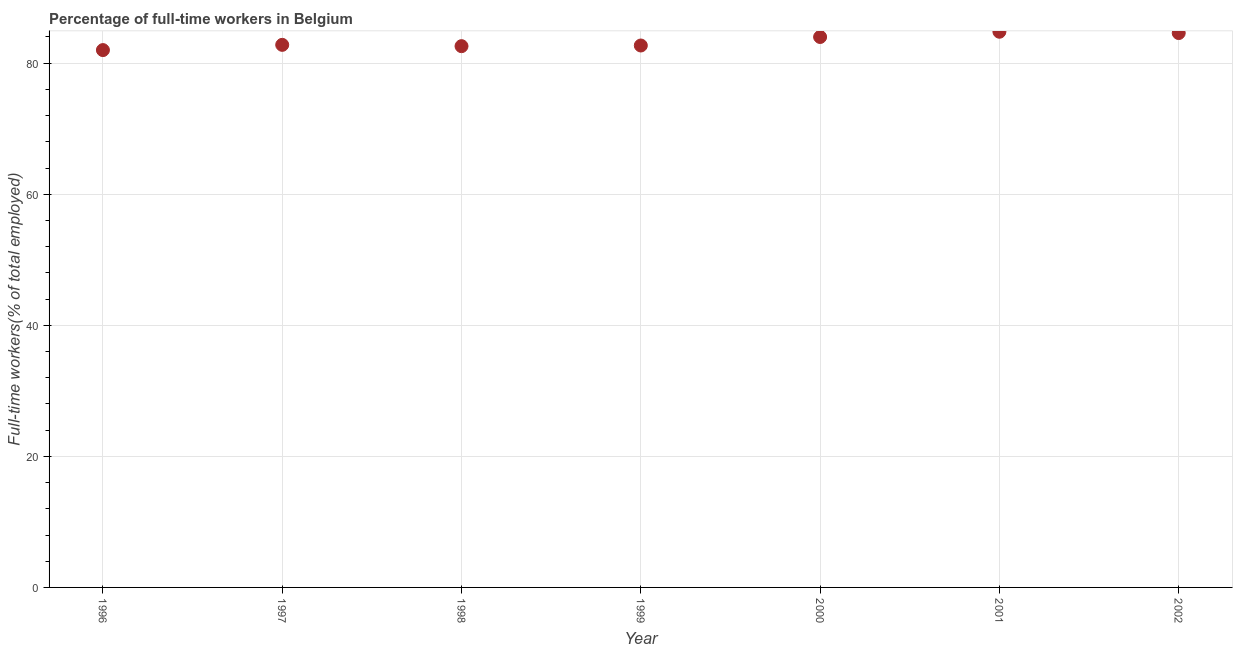What is the percentage of full-time workers in 2002?
Offer a terse response. 84.6. Across all years, what is the maximum percentage of full-time workers?
Offer a very short reply. 84.8. What is the sum of the percentage of full-time workers?
Provide a short and direct response. 583.5. What is the difference between the percentage of full-time workers in 1996 and 2002?
Keep it short and to the point. -2.6. What is the average percentage of full-time workers per year?
Provide a short and direct response. 83.36. What is the median percentage of full-time workers?
Provide a succinct answer. 82.8. What is the ratio of the percentage of full-time workers in 1996 to that in 1997?
Offer a very short reply. 0.99. Is the percentage of full-time workers in 1997 less than that in 2001?
Provide a succinct answer. Yes. Is the difference between the percentage of full-time workers in 1997 and 2002 greater than the difference between any two years?
Your answer should be very brief. No. What is the difference between the highest and the second highest percentage of full-time workers?
Provide a succinct answer. 0.2. Is the sum of the percentage of full-time workers in 2000 and 2002 greater than the maximum percentage of full-time workers across all years?
Provide a succinct answer. Yes. What is the difference between the highest and the lowest percentage of full-time workers?
Keep it short and to the point. 2.8. In how many years, is the percentage of full-time workers greater than the average percentage of full-time workers taken over all years?
Your answer should be compact. 3. Does the percentage of full-time workers monotonically increase over the years?
Your answer should be compact. No. How many dotlines are there?
Offer a terse response. 1. How many years are there in the graph?
Your response must be concise. 7. What is the difference between two consecutive major ticks on the Y-axis?
Offer a very short reply. 20. Does the graph contain any zero values?
Provide a short and direct response. No. What is the title of the graph?
Provide a short and direct response. Percentage of full-time workers in Belgium. What is the label or title of the X-axis?
Your answer should be very brief. Year. What is the label or title of the Y-axis?
Keep it short and to the point. Full-time workers(% of total employed). What is the Full-time workers(% of total employed) in 1996?
Your answer should be very brief. 82. What is the Full-time workers(% of total employed) in 1997?
Provide a succinct answer. 82.8. What is the Full-time workers(% of total employed) in 1998?
Your answer should be compact. 82.6. What is the Full-time workers(% of total employed) in 1999?
Provide a short and direct response. 82.7. What is the Full-time workers(% of total employed) in 2000?
Ensure brevity in your answer.  84. What is the Full-time workers(% of total employed) in 2001?
Provide a succinct answer. 84.8. What is the Full-time workers(% of total employed) in 2002?
Keep it short and to the point. 84.6. What is the difference between the Full-time workers(% of total employed) in 1996 and 1997?
Provide a succinct answer. -0.8. What is the difference between the Full-time workers(% of total employed) in 1996 and 1999?
Your response must be concise. -0.7. What is the difference between the Full-time workers(% of total employed) in 1996 and 2001?
Make the answer very short. -2.8. What is the difference between the Full-time workers(% of total employed) in 1997 and 1999?
Your answer should be compact. 0.1. What is the difference between the Full-time workers(% of total employed) in 1997 and 2000?
Ensure brevity in your answer.  -1.2. What is the difference between the Full-time workers(% of total employed) in 1997 and 2002?
Provide a succinct answer. -1.8. What is the difference between the Full-time workers(% of total employed) in 1998 and 1999?
Give a very brief answer. -0.1. What is the difference between the Full-time workers(% of total employed) in 1998 and 2002?
Provide a succinct answer. -2. What is the difference between the Full-time workers(% of total employed) in 1999 and 2001?
Your answer should be compact. -2.1. What is the difference between the Full-time workers(% of total employed) in 1999 and 2002?
Provide a short and direct response. -1.9. What is the difference between the Full-time workers(% of total employed) in 2000 and 2002?
Offer a very short reply. -0.6. What is the difference between the Full-time workers(% of total employed) in 2001 and 2002?
Ensure brevity in your answer.  0.2. What is the ratio of the Full-time workers(% of total employed) in 1996 to that in 1997?
Give a very brief answer. 0.99. What is the ratio of the Full-time workers(% of total employed) in 1996 to that in 2000?
Ensure brevity in your answer.  0.98. What is the ratio of the Full-time workers(% of total employed) in 1996 to that in 2002?
Make the answer very short. 0.97. What is the ratio of the Full-time workers(% of total employed) in 1997 to that in 1998?
Ensure brevity in your answer.  1. What is the ratio of the Full-time workers(% of total employed) in 1997 to that in 1999?
Offer a very short reply. 1. What is the ratio of the Full-time workers(% of total employed) in 1997 to that in 2000?
Give a very brief answer. 0.99. What is the ratio of the Full-time workers(% of total employed) in 1998 to that in 1999?
Your response must be concise. 1. What is the ratio of the Full-time workers(% of total employed) in 1998 to that in 2001?
Ensure brevity in your answer.  0.97. What is the ratio of the Full-time workers(% of total employed) in 1999 to that in 2000?
Provide a succinct answer. 0.98. What is the ratio of the Full-time workers(% of total employed) in 1999 to that in 2001?
Your answer should be very brief. 0.97. What is the ratio of the Full-time workers(% of total employed) in 2000 to that in 2001?
Your answer should be compact. 0.99. What is the ratio of the Full-time workers(% of total employed) in 2001 to that in 2002?
Ensure brevity in your answer.  1. 